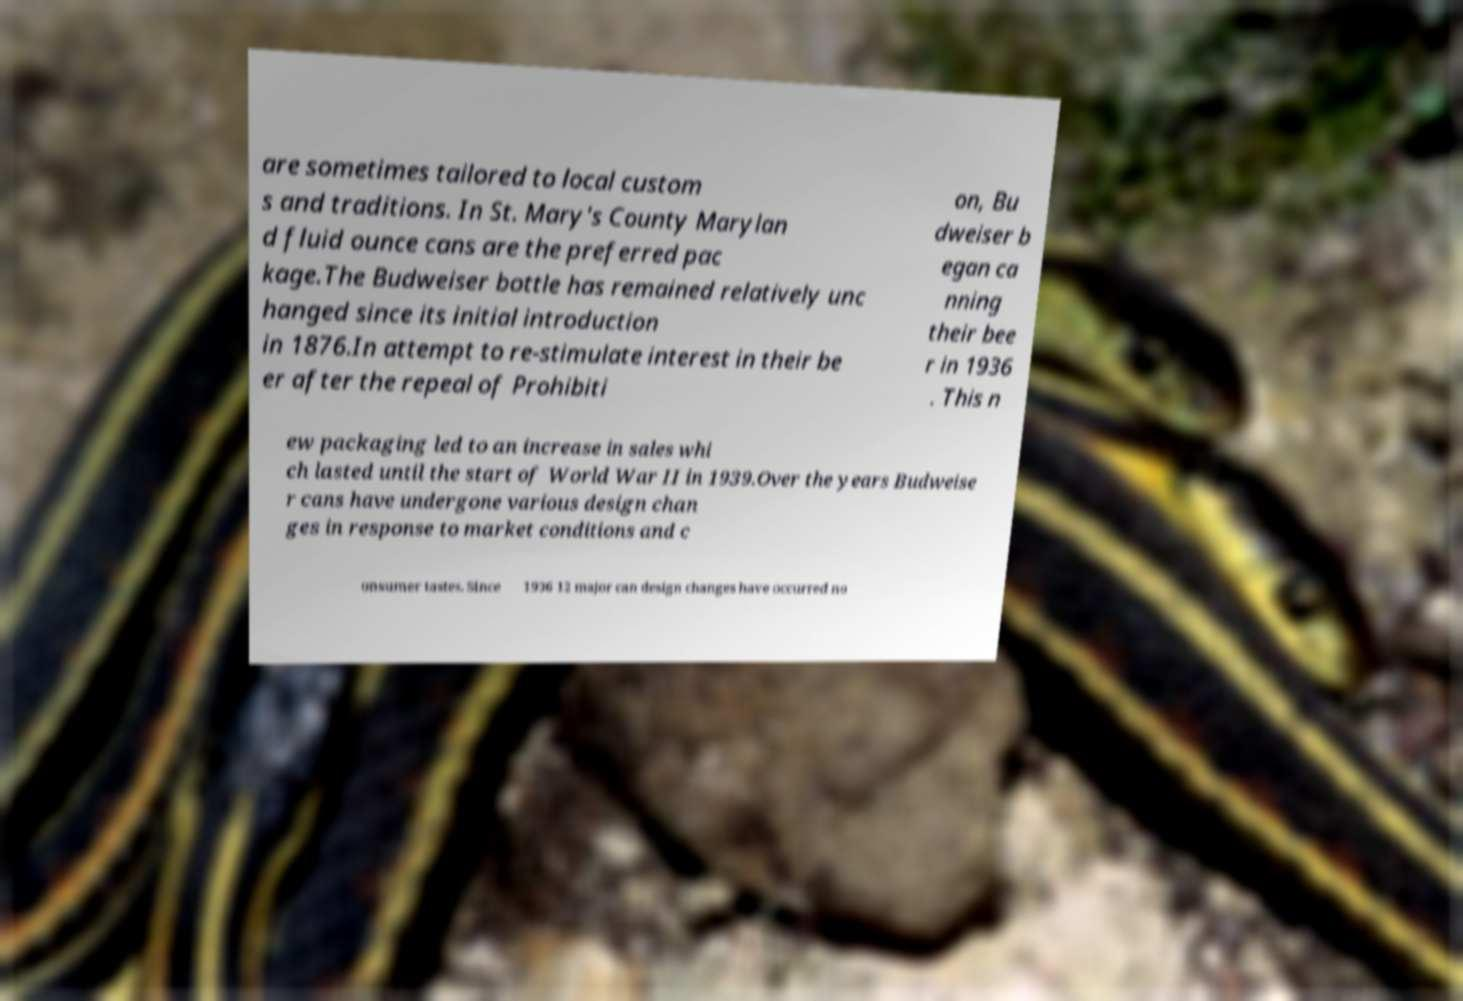Can you accurately transcribe the text from the provided image for me? are sometimes tailored to local custom s and traditions. In St. Mary's County Marylan d fluid ounce cans are the preferred pac kage.The Budweiser bottle has remained relatively unc hanged since its initial introduction in 1876.In attempt to re-stimulate interest in their be er after the repeal of Prohibiti on, Bu dweiser b egan ca nning their bee r in 1936 . This n ew packaging led to an increase in sales whi ch lasted until the start of World War II in 1939.Over the years Budweise r cans have undergone various design chan ges in response to market conditions and c onsumer tastes. Since 1936 12 major can design changes have occurred no 